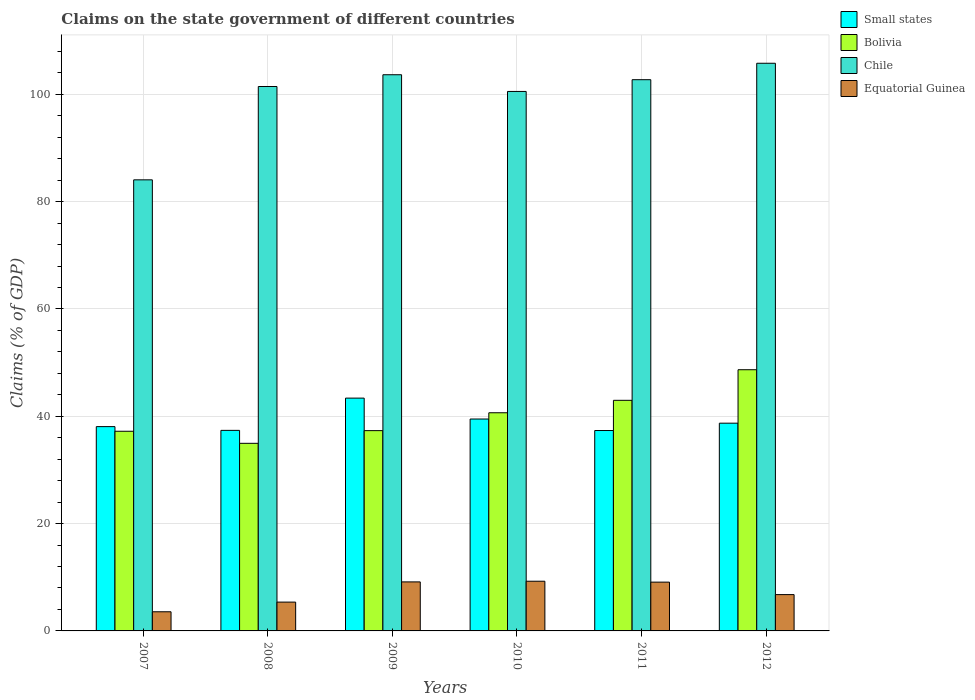How many different coloured bars are there?
Give a very brief answer. 4. Are the number of bars on each tick of the X-axis equal?
Ensure brevity in your answer.  Yes. How many bars are there on the 3rd tick from the left?
Your response must be concise. 4. How many bars are there on the 4th tick from the right?
Ensure brevity in your answer.  4. In how many cases, is the number of bars for a given year not equal to the number of legend labels?
Offer a very short reply. 0. What is the percentage of GDP claimed on the state government in Bolivia in 2012?
Offer a terse response. 48.68. Across all years, what is the maximum percentage of GDP claimed on the state government in Equatorial Guinea?
Offer a very short reply. 9.26. Across all years, what is the minimum percentage of GDP claimed on the state government in Bolivia?
Your response must be concise. 34.96. In which year was the percentage of GDP claimed on the state government in Equatorial Guinea maximum?
Provide a succinct answer. 2010. In which year was the percentage of GDP claimed on the state government in Equatorial Guinea minimum?
Give a very brief answer. 2007. What is the total percentage of GDP claimed on the state government in Small states in the graph?
Provide a succinct answer. 234.38. What is the difference between the percentage of GDP claimed on the state government in Small states in 2007 and that in 2010?
Give a very brief answer. -1.41. What is the difference between the percentage of GDP claimed on the state government in Equatorial Guinea in 2011 and the percentage of GDP claimed on the state government in Chile in 2009?
Give a very brief answer. -94.55. What is the average percentage of GDP claimed on the state government in Equatorial Guinea per year?
Your response must be concise. 7.2. In the year 2008, what is the difference between the percentage of GDP claimed on the state government in Chile and percentage of GDP claimed on the state government in Small states?
Provide a short and direct response. 64.08. In how many years, is the percentage of GDP claimed on the state government in Bolivia greater than 72 %?
Keep it short and to the point. 0. What is the ratio of the percentage of GDP claimed on the state government in Bolivia in 2010 to that in 2012?
Make the answer very short. 0.84. Is the percentage of GDP claimed on the state government in Small states in 2009 less than that in 2011?
Provide a short and direct response. No. What is the difference between the highest and the second highest percentage of GDP claimed on the state government in Bolivia?
Keep it short and to the point. 5.7. What is the difference between the highest and the lowest percentage of GDP claimed on the state government in Equatorial Guinea?
Give a very brief answer. 5.69. Is it the case that in every year, the sum of the percentage of GDP claimed on the state government in Equatorial Guinea and percentage of GDP claimed on the state government in Bolivia is greater than the sum of percentage of GDP claimed on the state government in Chile and percentage of GDP claimed on the state government in Small states?
Provide a short and direct response. No. What does the 4th bar from the left in 2009 represents?
Provide a succinct answer. Equatorial Guinea. What does the 4th bar from the right in 2010 represents?
Your answer should be compact. Small states. How many bars are there?
Ensure brevity in your answer.  24. How many years are there in the graph?
Provide a short and direct response. 6. What is the difference between two consecutive major ticks on the Y-axis?
Your response must be concise. 20. Does the graph contain any zero values?
Make the answer very short. No. Where does the legend appear in the graph?
Your answer should be compact. Top right. What is the title of the graph?
Provide a short and direct response. Claims on the state government of different countries. Does "United States" appear as one of the legend labels in the graph?
Your response must be concise. No. What is the label or title of the Y-axis?
Your answer should be very brief. Claims (% of GDP). What is the Claims (% of GDP) of Small states in 2007?
Your response must be concise. 38.07. What is the Claims (% of GDP) in Bolivia in 2007?
Keep it short and to the point. 37.21. What is the Claims (% of GDP) in Chile in 2007?
Ensure brevity in your answer.  84.06. What is the Claims (% of GDP) in Equatorial Guinea in 2007?
Provide a short and direct response. 3.57. What is the Claims (% of GDP) in Small states in 2008?
Provide a succinct answer. 37.37. What is the Claims (% of GDP) of Bolivia in 2008?
Provide a short and direct response. 34.96. What is the Claims (% of GDP) in Chile in 2008?
Make the answer very short. 101.45. What is the Claims (% of GDP) of Equatorial Guinea in 2008?
Provide a short and direct response. 5.37. What is the Claims (% of GDP) in Small states in 2009?
Ensure brevity in your answer.  43.38. What is the Claims (% of GDP) in Bolivia in 2009?
Provide a short and direct response. 37.32. What is the Claims (% of GDP) of Chile in 2009?
Make the answer very short. 103.65. What is the Claims (% of GDP) of Equatorial Guinea in 2009?
Keep it short and to the point. 9.13. What is the Claims (% of GDP) of Small states in 2010?
Your response must be concise. 39.49. What is the Claims (% of GDP) of Bolivia in 2010?
Give a very brief answer. 40.65. What is the Claims (% of GDP) of Chile in 2010?
Give a very brief answer. 100.53. What is the Claims (% of GDP) in Equatorial Guinea in 2010?
Give a very brief answer. 9.26. What is the Claims (% of GDP) in Small states in 2011?
Ensure brevity in your answer.  37.35. What is the Claims (% of GDP) of Bolivia in 2011?
Your answer should be very brief. 42.97. What is the Claims (% of GDP) in Chile in 2011?
Make the answer very short. 102.72. What is the Claims (% of GDP) in Equatorial Guinea in 2011?
Provide a succinct answer. 9.09. What is the Claims (% of GDP) in Small states in 2012?
Your response must be concise. 38.71. What is the Claims (% of GDP) of Bolivia in 2012?
Offer a terse response. 48.68. What is the Claims (% of GDP) in Chile in 2012?
Ensure brevity in your answer.  105.79. What is the Claims (% of GDP) in Equatorial Guinea in 2012?
Make the answer very short. 6.77. Across all years, what is the maximum Claims (% of GDP) of Small states?
Provide a short and direct response. 43.38. Across all years, what is the maximum Claims (% of GDP) of Bolivia?
Offer a terse response. 48.68. Across all years, what is the maximum Claims (% of GDP) of Chile?
Make the answer very short. 105.79. Across all years, what is the maximum Claims (% of GDP) in Equatorial Guinea?
Your answer should be very brief. 9.26. Across all years, what is the minimum Claims (% of GDP) in Small states?
Keep it short and to the point. 37.35. Across all years, what is the minimum Claims (% of GDP) in Bolivia?
Provide a short and direct response. 34.96. Across all years, what is the minimum Claims (% of GDP) of Chile?
Ensure brevity in your answer.  84.06. Across all years, what is the minimum Claims (% of GDP) of Equatorial Guinea?
Your response must be concise. 3.57. What is the total Claims (% of GDP) in Small states in the graph?
Ensure brevity in your answer.  234.38. What is the total Claims (% of GDP) of Bolivia in the graph?
Make the answer very short. 241.8. What is the total Claims (% of GDP) of Chile in the graph?
Offer a very short reply. 598.2. What is the total Claims (% of GDP) in Equatorial Guinea in the graph?
Provide a short and direct response. 43.2. What is the difference between the Claims (% of GDP) in Small states in 2007 and that in 2008?
Provide a succinct answer. 0.7. What is the difference between the Claims (% of GDP) of Bolivia in 2007 and that in 2008?
Keep it short and to the point. 2.25. What is the difference between the Claims (% of GDP) in Chile in 2007 and that in 2008?
Your answer should be compact. -17.39. What is the difference between the Claims (% of GDP) of Equatorial Guinea in 2007 and that in 2008?
Your answer should be very brief. -1.8. What is the difference between the Claims (% of GDP) in Small states in 2007 and that in 2009?
Offer a very short reply. -5.31. What is the difference between the Claims (% of GDP) in Bolivia in 2007 and that in 2009?
Provide a short and direct response. -0.12. What is the difference between the Claims (% of GDP) of Chile in 2007 and that in 2009?
Give a very brief answer. -19.58. What is the difference between the Claims (% of GDP) in Equatorial Guinea in 2007 and that in 2009?
Offer a very short reply. -5.57. What is the difference between the Claims (% of GDP) of Small states in 2007 and that in 2010?
Offer a terse response. -1.41. What is the difference between the Claims (% of GDP) of Bolivia in 2007 and that in 2010?
Provide a short and direct response. -3.45. What is the difference between the Claims (% of GDP) in Chile in 2007 and that in 2010?
Your answer should be compact. -16.47. What is the difference between the Claims (% of GDP) in Equatorial Guinea in 2007 and that in 2010?
Give a very brief answer. -5.69. What is the difference between the Claims (% of GDP) in Small states in 2007 and that in 2011?
Ensure brevity in your answer.  0.73. What is the difference between the Claims (% of GDP) of Bolivia in 2007 and that in 2011?
Offer a terse response. -5.77. What is the difference between the Claims (% of GDP) in Chile in 2007 and that in 2011?
Your response must be concise. -18.66. What is the difference between the Claims (% of GDP) in Equatorial Guinea in 2007 and that in 2011?
Make the answer very short. -5.52. What is the difference between the Claims (% of GDP) in Small states in 2007 and that in 2012?
Make the answer very short. -0.64. What is the difference between the Claims (% of GDP) of Bolivia in 2007 and that in 2012?
Keep it short and to the point. -11.47. What is the difference between the Claims (% of GDP) in Chile in 2007 and that in 2012?
Give a very brief answer. -21.73. What is the difference between the Claims (% of GDP) of Equatorial Guinea in 2007 and that in 2012?
Keep it short and to the point. -3.2. What is the difference between the Claims (% of GDP) in Small states in 2008 and that in 2009?
Your answer should be very brief. -6.01. What is the difference between the Claims (% of GDP) in Bolivia in 2008 and that in 2009?
Offer a very short reply. -2.36. What is the difference between the Claims (% of GDP) in Chile in 2008 and that in 2009?
Make the answer very short. -2.19. What is the difference between the Claims (% of GDP) of Equatorial Guinea in 2008 and that in 2009?
Your answer should be compact. -3.76. What is the difference between the Claims (% of GDP) of Small states in 2008 and that in 2010?
Give a very brief answer. -2.12. What is the difference between the Claims (% of GDP) of Bolivia in 2008 and that in 2010?
Offer a very short reply. -5.7. What is the difference between the Claims (% of GDP) in Chile in 2008 and that in 2010?
Provide a short and direct response. 0.92. What is the difference between the Claims (% of GDP) in Equatorial Guinea in 2008 and that in 2010?
Give a very brief answer. -3.89. What is the difference between the Claims (% of GDP) in Small states in 2008 and that in 2011?
Provide a succinct answer. 0.03. What is the difference between the Claims (% of GDP) of Bolivia in 2008 and that in 2011?
Your answer should be very brief. -8.02. What is the difference between the Claims (% of GDP) in Chile in 2008 and that in 2011?
Your answer should be very brief. -1.27. What is the difference between the Claims (% of GDP) of Equatorial Guinea in 2008 and that in 2011?
Make the answer very short. -3.72. What is the difference between the Claims (% of GDP) of Small states in 2008 and that in 2012?
Keep it short and to the point. -1.34. What is the difference between the Claims (% of GDP) in Bolivia in 2008 and that in 2012?
Your answer should be very brief. -13.72. What is the difference between the Claims (% of GDP) of Chile in 2008 and that in 2012?
Your answer should be very brief. -4.33. What is the difference between the Claims (% of GDP) of Equatorial Guinea in 2008 and that in 2012?
Offer a terse response. -1.4. What is the difference between the Claims (% of GDP) in Small states in 2009 and that in 2010?
Provide a succinct answer. 3.9. What is the difference between the Claims (% of GDP) of Bolivia in 2009 and that in 2010?
Make the answer very short. -3.33. What is the difference between the Claims (% of GDP) in Chile in 2009 and that in 2010?
Offer a very short reply. 3.11. What is the difference between the Claims (% of GDP) in Equatorial Guinea in 2009 and that in 2010?
Your answer should be very brief. -0.13. What is the difference between the Claims (% of GDP) in Small states in 2009 and that in 2011?
Your answer should be compact. 6.04. What is the difference between the Claims (% of GDP) of Bolivia in 2009 and that in 2011?
Your response must be concise. -5.65. What is the difference between the Claims (% of GDP) of Chile in 2009 and that in 2011?
Provide a succinct answer. 0.92. What is the difference between the Claims (% of GDP) in Equatorial Guinea in 2009 and that in 2011?
Make the answer very short. 0.04. What is the difference between the Claims (% of GDP) in Small states in 2009 and that in 2012?
Your answer should be compact. 4.67. What is the difference between the Claims (% of GDP) in Bolivia in 2009 and that in 2012?
Ensure brevity in your answer.  -11.35. What is the difference between the Claims (% of GDP) of Chile in 2009 and that in 2012?
Offer a terse response. -2.14. What is the difference between the Claims (% of GDP) in Equatorial Guinea in 2009 and that in 2012?
Ensure brevity in your answer.  2.37. What is the difference between the Claims (% of GDP) of Small states in 2010 and that in 2011?
Your answer should be very brief. 2.14. What is the difference between the Claims (% of GDP) of Bolivia in 2010 and that in 2011?
Make the answer very short. -2.32. What is the difference between the Claims (% of GDP) in Chile in 2010 and that in 2011?
Your response must be concise. -2.19. What is the difference between the Claims (% of GDP) of Equatorial Guinea in 2010 and that in 2011?
Give a very brief answer. 0.17. What is the difference between the Claims (% of GDP) in Small states in 2010 and that in 2012?
Offer a terse response. 0.78. What is the difference between the Claims (% of GDP) in Bolivia in 2010 and that in 2012?
Keep it short and to the point. -8.02. What is the difference between the Claims (% of GDP) of Chile in 2010 and that in 2012?
Ensure brevity in your answer.  -5.25. What is the difference between the Claims (% of GDP) in Equatorial Guinea in 2010 and that in 2012?
Offer a very short reply. 2.49. What is the difference between the Claims (% of GDP) of Small states in 2011 and that in 2012?
Ensure brevity in your answer.  -1.37. What is the difference between the Claims (% of GDP) of Bolivia in 2011 and that in 2012?
Offer a very short reply. -5.7. What is the difference between the Claims (% of GDP) in Chile in 2011 and that in 2012?
Provide a short and direct response. -3.06. What is the difference between the Claims (% of GDP) of Equatorial Guinea in 2011 and that in 2012?
Your response must be concise. 2.32. What is the difference between the Claims (% of GDP) in Small states in 2007 and the Claims (% of GDP) in Bolivia in 2008?
Your answer should be compact. 3.11. What is the difference between the Claims (% of GDP) in Small states in 2007 and the Claims (% of GDP) in Chile in 2008?
Provide a short and direct response. -63.38. What is the difference between the Claims (% of GDP) of Small states in 2007 and the Claims (% of GDP) of Equatorial Guinea in 2008?
Ensure brevity in your answer.  32.7. What is the difference between the Claims (% of GDP) in Bolivia in 2007 and the Claims (% of GDP) in Chile in 2008?
Give a very brief answer. -64.24. What is the difference between the Claims (% of GDP) in Bolivia in 2007 and the Claims (% of GDP) in Equatorial Guinea in 2008?
Your answer should be compact. 31.84. What is the difference between the Claims (% of GDP) in Chile in 2007 and the Claims (% of GDP) in Equatorial Guinea in 2008?
Your answer should be compact. 78.69. What is the difference between the Claims (% of GDP) in Small states in 2007 and the Claims (% of GDP) in Bolivia in 2009?
Make the answer very short. 0.75. What is the difference between the Claims (% of GDP) of Small states in 2007 and the Claims (% of GDP) of Chile in 2009?
Offer a terse response. -65.57. What is the difference between the Claims (% of GDP) of Small states in 2007 and the Claims (% of GDP) of Equatorial Guinea in 2009?
Make the answer very short. 28.94. What is the difference between the Claims (% of GDP) of Bolivia in 2007 and the Claims (% of GDP) of Chile in 2009?
Make the answer very short. -66.44. What is the difference between the Claims (% of GDP) of Bolivia in 2007 and the Claims (% of GDP) of Equatorial Guinea in 2009?
Keep it short and to the point. 28.07. What is the difference between the Claims (% of GDP) in Chile in 2007 and the Claims (% of GDP) in Equatorial Guinea in 2009?
Provide a succinct answer. 74.93. What is the difference between the Claims (% of GDP) of Small states in 2007 and the Claims (% of GDP) of Bolivia in 2010?
Your response must be concise. -2.58. What is the difference between the Claims (% of GDP) in Small states in 2007 and the Claims (% of GDP) in Chile in 2010?
Ensure brevity in your answer.  -62.46. What is the difference between the Claims (% of GDP) of Small states in 2007 and the Claims (% of GDP) of Equatorial Guinea in 2010?
Provide a succinct answer. 28.81. What is the difference between the Claims (% of GDP) of Bolivia in 2007 and the Claims (% of GDP) of Chile in 2010?
Keep it short and to the point. -63.32. What is the difference between the Claims (% of GDP) in Bolivia in 2007 and the Claims (% of GDP) in Equatorial Guinea in 2010?
Keep it short and to the point. 27.95. What is the difference between the Claims (% of GDP) in Chile in 2007 and the Claims (% of GDP) in Equatorial Guinea in 2010?
Make the answer very short. 74.8. What is the difference between the Claims (% of GDP) of Small states in 2007 and the Claims (% of GDP) of Bolivia in 2011?
Your answer should be compact. -4.9. What is the difference between the Claims (% of GDP) of Small states in 2007 and the Claims (% of GDP) of Chile in 2011?
Offer a terse response. -64.65. What is the difference between the Claims (% of GDP) of Small states in 2007 and the Claims (% of GDP) of Equatorial Guinea in 2011?
Provide a succinct answer. 28.98. What is the difference between the Claims (% of GDP) of Bolivia in 2007 and the Claims (% of GDP) of Chile in 2011?
Offer a terse response. -65.51. What is the difference between the Claims (% of GDP) in Bolivia in 2007 and the Claims (% of GDP) in Equatorial Guinea in 2011?
Your response must be concise. 28.12. What is the difference between the Claims (% of GDP) of Chile in 2007 and the Claims (% of GDP) of Equatorial Guinea in 2011?
Your answer should be compact. 74.97. What is the difference between the Claims (% of GDP) of Small states in 2007 and the Claims (% of GDP) of Bolivia in 2012?
Offer a very short reply. -10.6. What is the difference between the Claims (% of GDP) of Small states in 2007 and the Claims (% of GDP) of Chile in 2012?
Provide a succinct answer. -67.71. What is the difference between the Claims (% of GDP) in Small states in 2007 and the Claims (% of GDP) in Equatorial Guinea in 2012?
Give a very brief answer. 31.3. What is the difference between the Claims (% of GDP) in Bolivia in 2007 and the Claims (% of GDP) in Chile in 2012?
Your response must be concise. -68.58. What is the difference between the Claims (% of GDP) in Bolivia in 2007 and the Claims (% of GDP) in Equatorial Guinea in 2012?
Give a very brief answer. 30.44. What is the difference between the Claims (% of GDP) of Chile in 2007 and the Claims (% of GDP) of Equatorial Guinea in 2012?
Your response must be concise. 77.29. What is the difference between the Claims (% of GDP) in Small states in 2008 and the Claims (% of GDP) in Bolivia in 2009?
Give a very brief answer. 0.05. What is the difference between the Claims (% of GDP) of Small states in 2008 and the Claims (% of GDP) of Chile in 2009?
Provide a succinct answer. -66.27. What is the difference between the Claims (% of GDP) of Small states in 2008 and the Claims (% of GDP) of Equatorial Guinea in 2009?
Give a very brief answer. 28.24. What is the difference between the Claims (% of GDP) in Bolivia in 2008 and the Claims (% of GDP) in Chile in 2009?
Ensure brevity in your answer.  -68.69. What is the difference between the Claims (% of GDP) of Bolivia in 2008 and the Claims (% of GDP) of Equatorial Guinea in 2009?
Provide a succinct answer. 25.82. What is the difference between the Claims (% of GDP) of Chile in 2008 and the Claims (% of GDP) of Equatorial Guinea in 2009?
Provide a short and direct response. 92.32. What is the difference between the Claims (% of GDP) in Small states in 2008 and the Claims (% of GDP) in Bolivia in 2010?
Keep it short and to the point. -3.28. What is the difference between the Claims (% of GDP) of Small states in 2008 and the Claims (% of GDP) of Chile in 2010?
Make the answer very short. -63.16. What is the difference between the Claims (% of GDP) of Small states in 2008 and the Claims (% of GDP) of Equatorial Guinea in 2010?
Your answer should be very brief. 28.11. What is the difference between the Claims (% of GDP) of Bolivia in 2008 and the Claims (% of GDP) of Chile in 2010?
Keep it short and to the point. -65.57. What is the difference between the Claims (% of GDP) in Bolivia in 2008 and the Claims (% of GDP) in Equatorial Guinea in 2010?
Make the answer very short. 25.7. What is the difference between the Claims (% of GDP) in Chile in 2008 and the Claims (% of GDP) in Equatorial Guinea in 2010?
Provide a short and direct response. 92.19. What is the difference between the Claims (% of GDP) of Small states in 2008 and the Claims (% of GDP) of Bolivia in 2011?
Your answer should be compact. -5.6. What is the difference between the Claims (% of GDP) in Small states in 2008 and the Claims (% of GDP) in Chile in 2011?
Your response must be concise. -65.35. What is the difference between the Claims (% of GDP) in Small states in 2008 and the Claims (% of GDP) in Equatorial Guinea in 2011?
Provide a short and direct response. 28.28. What is the difference between the Claims (% of GDP) of Bolivia in 2008 and the Claims (% of GDP) of Chile in 2011?
Give a very brief answer. -67.76. What is the difference between the Claims (% of GDP) in Bolivia in 2008 and the Claims (% of GDP) in Equatorial Guinea in 2011?
Offer a terse response. 25.87. What is the difference between the Claims (% of GDP) in Chile in 2008 and the Claims (% of GDP) in Equatorial Guinea in 2011?
Your answer should be compact. 92.36. What is the difference between the Claims (% of GDP) of Small states in 2008 and the Claims (% of GDP) of Bolivia in 2012?
Keep it short and to the point. -11.3. What is the difference between the Claims (% of GDP) in Small states in 2008 and the Claims (% of GDP) in Chile in 2012?
Your response must be concise. -68.41. What is the difference between the Claims (% of GDP) in Small states in 2008 and the Claims (% of GDP) in Equatorial Guinea in 2012?
Ensure brevity in your answer.  30.6. What is the difference between the Claims (% of GDP) in Bolivia in 2008 and the Claims (% of GDP) in Chile in 2012?
Make the answer very short. -70.83. What is the difference between the Claims (% of GDP) of Bolivia in 2008 and the Claims (% of GDP) of Equatorial Guinea in 2012?
Keep it short and to the point. 28.19. What is the difference between the Claims (% of GDP) in Chile in 2008 and the Claims (% of GDP) in Equatorial Guinea in 2012?
Give a very brief answer. 94.68. What is the difference between the Claims (% of GDP) of Small states in 2009 and the Claims (% of GDP) of Bolivia in 2010?
Your answer should be compact. 2.73. What is the difference between the Claims (% of GDP) of Small states in 2009 and the Claims (% of GDP) of Chile in 2010?
Keep it short and to the point. -57.15. What is the difference between the Claims (% of GDP) in Small states in 2009 and the Claims (% of GDP) in Equatorial Guinea in 2010?
Provide a short and direct response. 34.12. What is the difference between the Claims (% of GDP) of Bolivia in 2009 and the Claims (% of GDP) of Chile in 2010?
Your answer should be very brief. -63.21. What is the difference between the Claims (% of GDP) in Bolivia in 2009 and the Claims (% of GDP) in Equatorial Guinea in 2010?
Provide a short and direct response. 28.06. What is the difference between the Claims (% of GDP) in Chile in 2009 and the Claims (% of GDP) in Equatorial Guinea in 2010?
Offer a very short reply. 94.38. What is the difference between the Claims (% of GDP) of Small states in 2009 and the Claims (% of GDP) of Bolivia in 2011?
Provide a succinct answer. 0.41. What is the difference between the Claims (% of GDP) of Small states in 2009 and the Claims (% of GDP) of Chile in 2011?
Offer a terse response. -59.34. What is the difference between the Claims (% of GDP) in Small states in 2009 and the Claims (% of GDP) in Equatorial Guinea in 2011?
Your answer should be very brief. 34.29. What is the difference between the Claims (% of GDP) of Bolivia in 2009 and the Claims (% of GDP) of Chile in 2011?
Give a very brief answer. -65.4. What is the difference between the Claims (% of GDP) of Bolivia in 2009 and the Claims (% of GDP) of Equatorial Guinea in 2011?
Your response must be concise. 28.23. What is the difference between the Claims (% of GDP) in Chile in 2009 and the Claims (% of GDP) in Equatorial Guinea in 2011?
Your answer should be compact. 94.55. What is the difference between the Claims (% of GDP) in Small states in 2009 and the Claims (% of GDP) in Bolivia in 2012?
Ensure brevity in your answer.  -5.29. What is the difference between the Claims (% of GDP) in Small states in 2009 and the Claims (% of GDP) in Chile in 2012?
Ensure brevity in your answer.  -62.4. What is the difference between the Claims (% of GDP) of Small states in 2009 and the Claims (% of GDP) of Equatorial Guinea in 2012?
Ensure brevity in your answer.  36.61. What is the difference between the Claims (% of GDP) in Bolivia in 2009 and the Claims (% of GDP) in Chile in 2012?
Offer a very short reply. -68.46. What is the difference between the Claims (% of GDP) of Bolivia in 2009 and the Claims (% of GDP) of Equatorial Guinea in 2012?
Offer a very short reply. 30.55. What is the difference between the Claims (% of GDP) in Chile in 2009 and the Claims (% of GDP) in Equatorial Guinea in 2012?
Offer a very short reply. 96.88. What is the difference between the Claims (% of GDP) in Small states in 2010 and the Claims (% of GDP) in Bolivia in 2011?
Your answer should be very brief. -3.49. What is the difference between the Claims (% of GDP) of Small states in 2010 and the Claims (% of GDP) of Chile in 2011?
Your response must be concise. -63.23. What is the difference between the Claims (% of GDP) of Small states in 2010 and the Claims (% of GDP) of Equatorial Guinea in 2011?
Provide a short and direct response. 30.4. What is the difference between the Claims (% of GDP) of Bolivia in 2010 and the Claims (% of GDP) of Chile in 2011?
Make the answer very short. -62.07. What is the difference between the Claims (% of GDP) in Bolivia in 2010 and the Claims (% of GDP) in Equatorial Guinea in 2011?
Provide a short and direct response. 31.56. What is the difference between the Claims (% of GDP) of Chile in 2010 and the Claims (% of GDP) of Equatorial Guinea in 2011?
Your answer should be compact. 91.44. What is the difference between the Claims (% of GDP) of Small states in 2010 and the Claims (% of GDP) of Bolivia in 2012?
Provide a short and direct response. -9.19. What is the difference between the Claims (% of GDP) in Small states in 2010 and the Claims (% of GDP) in Chile in 2012?
Your answer should be compact. -66.3. What is the difference between the Claims (% of GDP) in Small states in 2010 and the Claims (% of GDP) in Equatorial Guinea in 2012?
Provide a succinct answer. 32.72. What is the difference between the Claims (% of GDP) of Bolivia in 2010 and the Claims (% of GDP) of Chile in 2012?
Your answer should be compact. -65.13. What is the difference between the Claims (% of GDP) in Bolivia in 2010 and the Claims (% of GDP) in Equatorial Guinea in 2012?
Your answer should be very brief. 33.89. What is the difference between the Claims (% of GDP) of Chile in 2010 and the Claims (% of GDP) of Equatorial Guinea in 2012?
Offer a very short reply. 93.76. What is the difference between the Claims (% of GDP) of Small states in 2011 and the Claims (% of GDP) of Bolivia in 2012?
Provide a succinct answer. -11.33. What is the difference between the Claims (% of GDP) of Small states in 2011 and the Claims (% of GDP) of Chile in 2012?
Offer a terse response. -68.44. What is the difference between the Claims (% of GDP) of Small states in 2011 and the Claims (% of GDP) of Equatorial Guinea in 2012?
Keep it short and to the point. 30.58. What is the difference between the Claims (% of GDP) of Bolivia in 2011 and the Claims (% of GDP) of Chile in 2012?
Offer a very short reply. -62.81. What is the difference between the Claims (% of GDP) of Bolivia in 2011 and the Claims (% of GDP) of Equatorial Guinea in 2012?
Ensure brevity in your answer.  36.21. What is the difference between the Claims (% of GDP) of Chile in 2011 and the Claims (% of GDP) of Equatorial Guinea in 2012?
Offer a very short reply. 95.95. What is the average Claims (% of GDP) in Small states per year?
Offer a very short reply. 39.06. What is the average Claims (% of GDP) of Bolivia per year?
Offer a terse response. 40.3. What is the average Claims (% of GDP) in Chile per year?
Your answer should be compact. 99.7. What is the average Claims (% of GDP) in Equatorial Guinea per year?
Give a very brief answer. 7.2. In the year 2007, what is the difference between the Claims (% of GDP) of Small states and Claims (% of GDP) of Bolivia?
Provide a short and direct response. 0.86. In the year 2007, what is the difference between the Claims (% of GDP) of Small states and Claims (% of GDP) of Chile?
Offer a terse response. -45.99. In the year 2007, what is the difference between the Claims (% of GDP) in Small states and Claims (% of GDP) in Equatorial Guinea?
Provide a succinct answer. 34.51. In the year 2007, what is the difference between the Claims (% of GDP) in Bolivia and Claims (% of GDP) in Chile?
Offer a terse response. -46.85. In the year 2007, what is the difference between the Claims (% of GDP) of Bolivia and Claims (% of GDP) of Equatorial Guinea?
Offer a terse response. 33.64. In the year 2007, what is the difference between the Claims (% of GDP) of Chile and Claims (% of GDP) of Equatorial Guinea?
Your answer should be compact. 80.49. In the year 2008, what is the difference between the Claims (% of GDP) in Small states and Claims (% of GDP) in Bolivia?
Make the answer very short. 2.41. In the year 2008, what is the difference between the Claims (% of GDP) in Small states and Claims (% of GDP) in Chile?
Your answer should be compact. -64.08. In the year 2008, what is the difference between the Claims (% of GDP) of Small states and Claims (% of GDP) of Equatorial Guinea?
Give a very brief answer. 32. In the year 2008, what is the difference between the Claims (% of GDP) of Bolivia and Claims (% of GDP) of Chile?
Make the answer very short. -66.49. In the year 2008, what is the difference between the Claims (% of GDP) in Bolivia and Claims (% of GDP) in Equatorial Guinea?
Offer a terse response. 29.59. In the year 2008, what is the difference between the Claims (% of GDP) in Chile and Claims (% of GDP) in Equatorial Guinea?
Provide a short and direct response. 96.08. In the year 2009, what is the difference between the Claims (% of GDP) in Small states and Claims (% of GDP) in Bolivia?
Your answer should be compact. 6.06. In the year 2009, what is the difference between the Claims (% of GDP) in Small states and Claims (% of GDP) in Chile?
Offer a terse response. -60.26. In the year 2009, what is the difference between the Claims (% of GDP) of Small states and Claims (% of GDP) of Equatorial Guinea?
Your answer should be very brief. 34.25. In the year 2009, what is the difference between the Claims (% of GDP) of Bolivia and Claims (% of GDP) of Chile?
Give a very brief answer. -66.32. In the year 2009, what is the difference between the Claims (% of GDP) of Bolivia and Claims (% of GDP) of Equatorial Guinea?
Offer a terse response. 28.19. In the year 2009, what is the difference between the Claims (% of GDP) in Chile and Claims (% of GDP) in Equatorial Guinea?
Your response must be concise. 94.51. In the year 2010, what is the difference between the Claims (% of GDP) of Small states and Claims (% of GDP) of Bolivia?
Your answer should be very brief. -1.17. In the year 2010, what is the difference between the Claims (% of GDP) of Small states and Claims (% of GDP) of Chile?
Give a very brief answer. -61.04. In the year 2010, what is the difference between the Claims (% of GDP) in Small states and Claims (% of GDP) in Equatorial Guinea?
Offer a very short reply. 30.23. In the year 2010, what is the difference between the Claims (% of GDP) of Bolivia and Claims (% of GDP) of Chile?
Make the answer very short. -59.88. In the year 2010, what is the difference between the Claims (% of GDP) of Bolivia and Claims (% of GDP) of Equatorial Guinea?
Your answer should be compact. 31.39. In the year 2010, what is the difference between the Claims (% of GDP) of Chile and Claims (% of GDP) of Equatorial Guinea?
Keep it short and to the point. 91.27. In the year 2011, what is the difference between the Claims (% of GDP) in Small states and Claims (% of GDP) in Bolivia?
Offer a very short reply. -5.63. In the year 2011, what is the difference between the Claims (% of GDP) in Small states and Claims (% of GDP) in Chile?
Give a very brief answer. -65.38. In the year 2011, what is the difference between the Claims (% of GDP) in Small states and Claims (% of GDP) in Equatorial Guinea?
Give a very brief answer. 28.25. In the year 2011, what is the difference between the Claims (% of GDP) of Bolivia and Claims (% of GDP) of Chile?
Make the answer very short. -59.75. In the year 2011, what is the difference between the Claims (% of GDP) of Bolivia and Claims (% of GDP) of Equatorial Guinea?
Your answer should be compact. 33.88. In the year 2011, what is the difference between the Claims (% of GDP) in Chile and Claims (% of GDP) in Equatorial Guinea?
Ensure brevity in your answer.  93.63. In the year 2012, what is the difference between the Claims (% of GDP) in Small states and Claims (% of GDP) in Bolivia?
Offer a very short reply. -9.96. In the year 2012, what is the difference between the Claims (% of GDP) in Small states and Claims (% of GDP) in Chile?
Your answer should be compact. -67.07. In the year 2012, what is the difference between the Claims (% of GDP) in Small states and Claims (% of GDP) in Equatorial Guinea?
Your answer should be compact. 31.94. In the year 2012, what is the difference between the Claims (% of GDP) of Bolivia and Claims (% of GDP) of Chile?
Your response must be concise. -57.11. In the year 2012, what is the difference between the Claims (% of GDP) in Bolivia and Claims (% of GDP) in Equatorial Guinea?
Ensure brevity in your answer.  41.91. In the year 2012, what is the difference between the Claims (% of GDP) of Chile and Claims (% of GDP) of Equatorial Guinea?
Keep it short and to the point. 99.02. What is the ratio of the Claims (% of GDP) of Small states in 2007 to that in 2008?
Your response must be concise. 1.02. What is the ratio of the Claims (% of GDP) of Bolivia in 2007 to that in 2008?
Keep it short and to the point. 1.06. What is the ratio of the Claims (% of GDP) of Chile in 2007 to that in 2008?
Your answer should be compact. 0.83. What is the ratio of the Claims (% of GDP) of Equatorial Guinea in 2007 to that in 2008?
Offer a very short reply. 0.66. What is the ratio of the Claims (% of GDP) in Small states in 2007 to that in 2009?
Provide a succinct answer. 0.88. What is the ratio of the Claims (% of GDP) in Chile in 2007 to that in 2009?
Make the answer very short. 0.81. What is the ratio of the Claims (% of GDP) in Equatorial Guinea in 2007 to that in 2009?
Your answer should be very brief. 0.39. What is the ratio of the Claims (% of GDP) of Small states in 2007 to that in 2010?
Your answer should be very brief. 0.96. What is the ratio of the Claims (% of GDP) of Bolivia in 2007 to that in 2010?
Give a very brief answer. 0.92. What is the ratio of the Claims (% of GDP) of Chile in 2007 to that in 2010?
Make the answer very short. 0.84. What is the ratio of the Claims (% of GDP) in Equatorial Guinea in 2007 to that in 2010?
Ensure brevity in your answer.  0.39. What is the ratio of the Claims (% of GDP) in Small states in 2007 to that in 2011?
Provide a succinct answer. 1.02. What is the ratio of the Claims (% of GDP) of Bolivia in 2007 to that in 2011?
Ensure brevity in your answer.  0.87. What is the ratio of the Claims (% of GDP) in Chile in 2007 to that in 2011?
Give a very brief answer. 0.82. What is the ratio of the Claims (% of GDP) of Equatorial Guinea in 2007 to that in 2011?
Your answer should be very brief. 0.39. What is the ratio of the Claims (% of GDP) in Small states in 2007 to that in 2012?
Your response must be concise. 0.98. What is the ratio of the Claims (% of GDP) in Bolivia in 2007 to that in 2012?
Your answer should be compact. 0.76. What is the ratio of the Claims (% of GDP) in Chile in 2007 to that in 2012?
Provide a short and direct response. 0.79. What is the ratio of the Claims (% of GDP) in Equatorial Guinea in 2007 to that in 2012?
Offer a very short reply. 0.53. What is the ratio of the Claims (% of GDP) in Small states in 2008 to that in 2009?
Provide a succinct answer. 0.86. What is the ratio of the Claims (% of GDP) of Bolivia in 2008 to that in 2009?
Your answer should be very brief. 0.94. What is the ratio of the Claims (% of GDP) of Chile in 2008 to that in 2009?
Provide a short and direct response. 0.98. What is the ratio of the Claims (% of GDP) of Equatorial Guinea in 2008 to that in 2009?
Ensure brevity in your answer.  0.59. What is the ratio of the Claims (% of GDP) of Small states in 2008 to that in 2010?
Provide a succinct answer. 0.95. What is the ratio of the Claims (% of GDP) in Bolivia in 2008 to that in 2010?
Provide a succinct answer. 0.86. What is the ratio of the Claims (% of GDP) in Chile in 2008 to that in 2010?
Your response must be concise. 1.01. What is the ratio of the Claims (% of GDP) in Equatorial Guinea in 2008 to that in 2010?
Give a very brief answer. 0.58. What is the ratio of the Claims (% of GDP) of Small states in 2008 to that in 2011?
Your response must be concise. 1. What is the ratio of the Claims (% of GDP) of Bolivia in 2008 to that in 2011?
Make the answer very short. 0.81. What is the ratio of the Claims (% of GDP) in Chile in 2008 to that in 2011?
Give a very brief answer. 0.99. What is the ratio of the Claims (% of GDP) in Equatorial Guinea in 2008 to that in 2011?
Keep it short and to the point. 0.59. What is the ratio of the Claims (% of GDP) in Small states in 2008 to that in 2012?
Your response must be concise. 0.97. What is the ratio of the Claims (% of GDP) in Bolivia in 2008 to that in 2012?
Provide a short and direct response. 0.72. What is the ratio of the Claims (% of GDP) of Chile in 2008 to that in 2012?
Your response must be concise. 0.96. What is the ratio of the Claims (% of GDP) in Equatorial Guinea in 2008 to that in 2012?
Offer a terse response. 0.79. What is the ratio of the Claims (% of GDP) of Small states in 2009 to that in 2010?
Ensure brevity in your answer.  1.1. What is the ratio of the Claims (% of GDP) of Bolivia in 2009 to that in 2010?
Provide a succinct answer. 0.92. What is the ratio of the Claims (% of GDP) in Chile in 2009 to that in 2010?
Give a very brief answer. 1.03. What is the ratio of the Claims (% of GDP) in Equatorial Guinea in 2009 to that in 2010?
Provide a short and direct response. 0.99. What is the ratio of the Claims (% of GDP) of Small states in 2009 to that in 2011?
Your response must be concise. 1.16. What is the ratio of the Claims (% of GDP) in Bolivia in 2009 to that in 2011?
Offer a terse response. 0.87. What is the ratio of the Claims (% of GDP) of Small states in 2009 to that in 2012?
Offer a very short reply. 1.12. What is the ratio of the Claims (% of GDP) in Bolivia in 2009 to that in 2012?
Your answer should be very brief. 0.77. What is the ratio of the Claims (% of GDP) in Chile in 2009 to that in 2012?
Provide a succinct answer. 0.98. What is the ratio of the Claims (% of GDP) in Equatorial Guinea in 2009 to that in 2012?
Make the answer very short. 1.35. What is the ratio of the Claims (% of GDP) in Small states in 2010 to that in 2011?
Ensure brevity in your answer.  1.06. What is the ratio of the Claims (% of GDP) in Bolivia in 2010 to that in 2011?
Your answer should be compact. 0.95. What is the ratio of the Claims (% of GDP) of Chile in 2010 to that in 2011?
Offer a very short reply. 0.98. What is the ratio of the Claims (% of GDP) of Equatorial Guinea in 2010 to that in 2011?
Give a very brief answer. 1.02. What is the ratio of the Claims (% of GDP) in Small states in 2010 to that in 2012?
Ensure brevity in your answer.  1.02. What is the ratio of the Claims (% of GDP) in Bolivia in 2010 to that in 2012?
Ensure brevity in your answer.  0.84. What is the ratio of the Claims (% of GDP) in Chile in 2010 to that in 2012?
Your answer should be very brief. 0.95. What is the ratio of the Claims (% of GDP) in Equatorial Guinea in 2010 to that in 2012?
Your response must be concise. 1.37. What is the ratio of the Claims (% of GDP) of Small states in 2011 to that in 2012?
Give a very brief answer. 0.96. What is the ratio of the Claims (% of GDP) in Bolivia in 2011 to that in 2012?
Provide a short and direct response. 0.88. What is the ratio of the Claims (% of GDP) in Equatorial Guinea in 2011 to that in 2012?
Ensure brevity in your answer.  1.34. What is the difference between the highest and the second highest Claims (% of GDP) in Small states?
Give a very brief answer. 3.9. What is the difference between the highest and the second highest Claims (% of GDP) of Bolivia?
Your answer should be compact. 5.7. What is the difference between the highest and the second highest Claims (% of GDP) of Chile?
Offer a very short reply. 2.14. What is the difference between the highest and the second highest Claims (% of GDP) of Equatorial Guinea?
Ensure brevity in your answer.  0.13. What is the difference between the highest and the lowest Claims (% of GDP) in Small states?
Give a very brief answer. 6.04. What is the difference between the highest and the lowest Claims (% of GDP) of Bolivia?
Offer a terse response. 13.72. What is the difference between the highest and the lowest Claims (% of GDP) in Chile?
Offer a very short reply. 21.73. What is the difference between the highest and the lowest Claims (% of GDP) of Equatorial Guinea?
Provide a short and direct response. 5.69. 